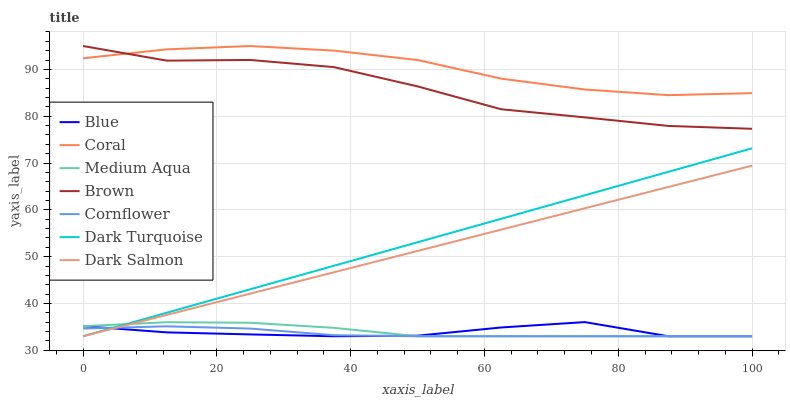Does Cornflower have the minimum area under the curve?
Answer yes or no. Yes. Does Coral have the maximum area under the curve?
Answer yes or no. Yes. Does Brown have the minimum area under the curve?
Answer yes or no. No. Does Brown have the maximum area under the curve?
Answer yes or no. No. Is Dark Turquoise the smoothest?
Answer yes or no. Yes. Is Brown the roughest?
Answer yes or no. Yes. Is Cornflower the smoothest?
Answer yes or no. No. Is Cornflower the roughest?
Answer yes or no. No. Does Blue have the lowest value?
Answer yes or no. Yes. Does Brown have the lowest value?
Answer yes or no. No. Does Coral have the highest value?
Answer yes or no. Yes. Does Cornflower have the highest value?
Answer yes or no. No. Is Medium Aqua less than Brown?
Answer yes or no. Yes. Is Coral greater than Dark Salmon?
Answer yes or no. Yes. Does Dark Turquoise intersect Blue?
Answer yes or no. Yes. Is Dark Turquoise less than Blue?
Answer yes or no. No. Is Dark Turquoise greater than Blue?
Answer yes or no. No. Does Medium Aqua intersect Brown?
Answer yes or no. No. 